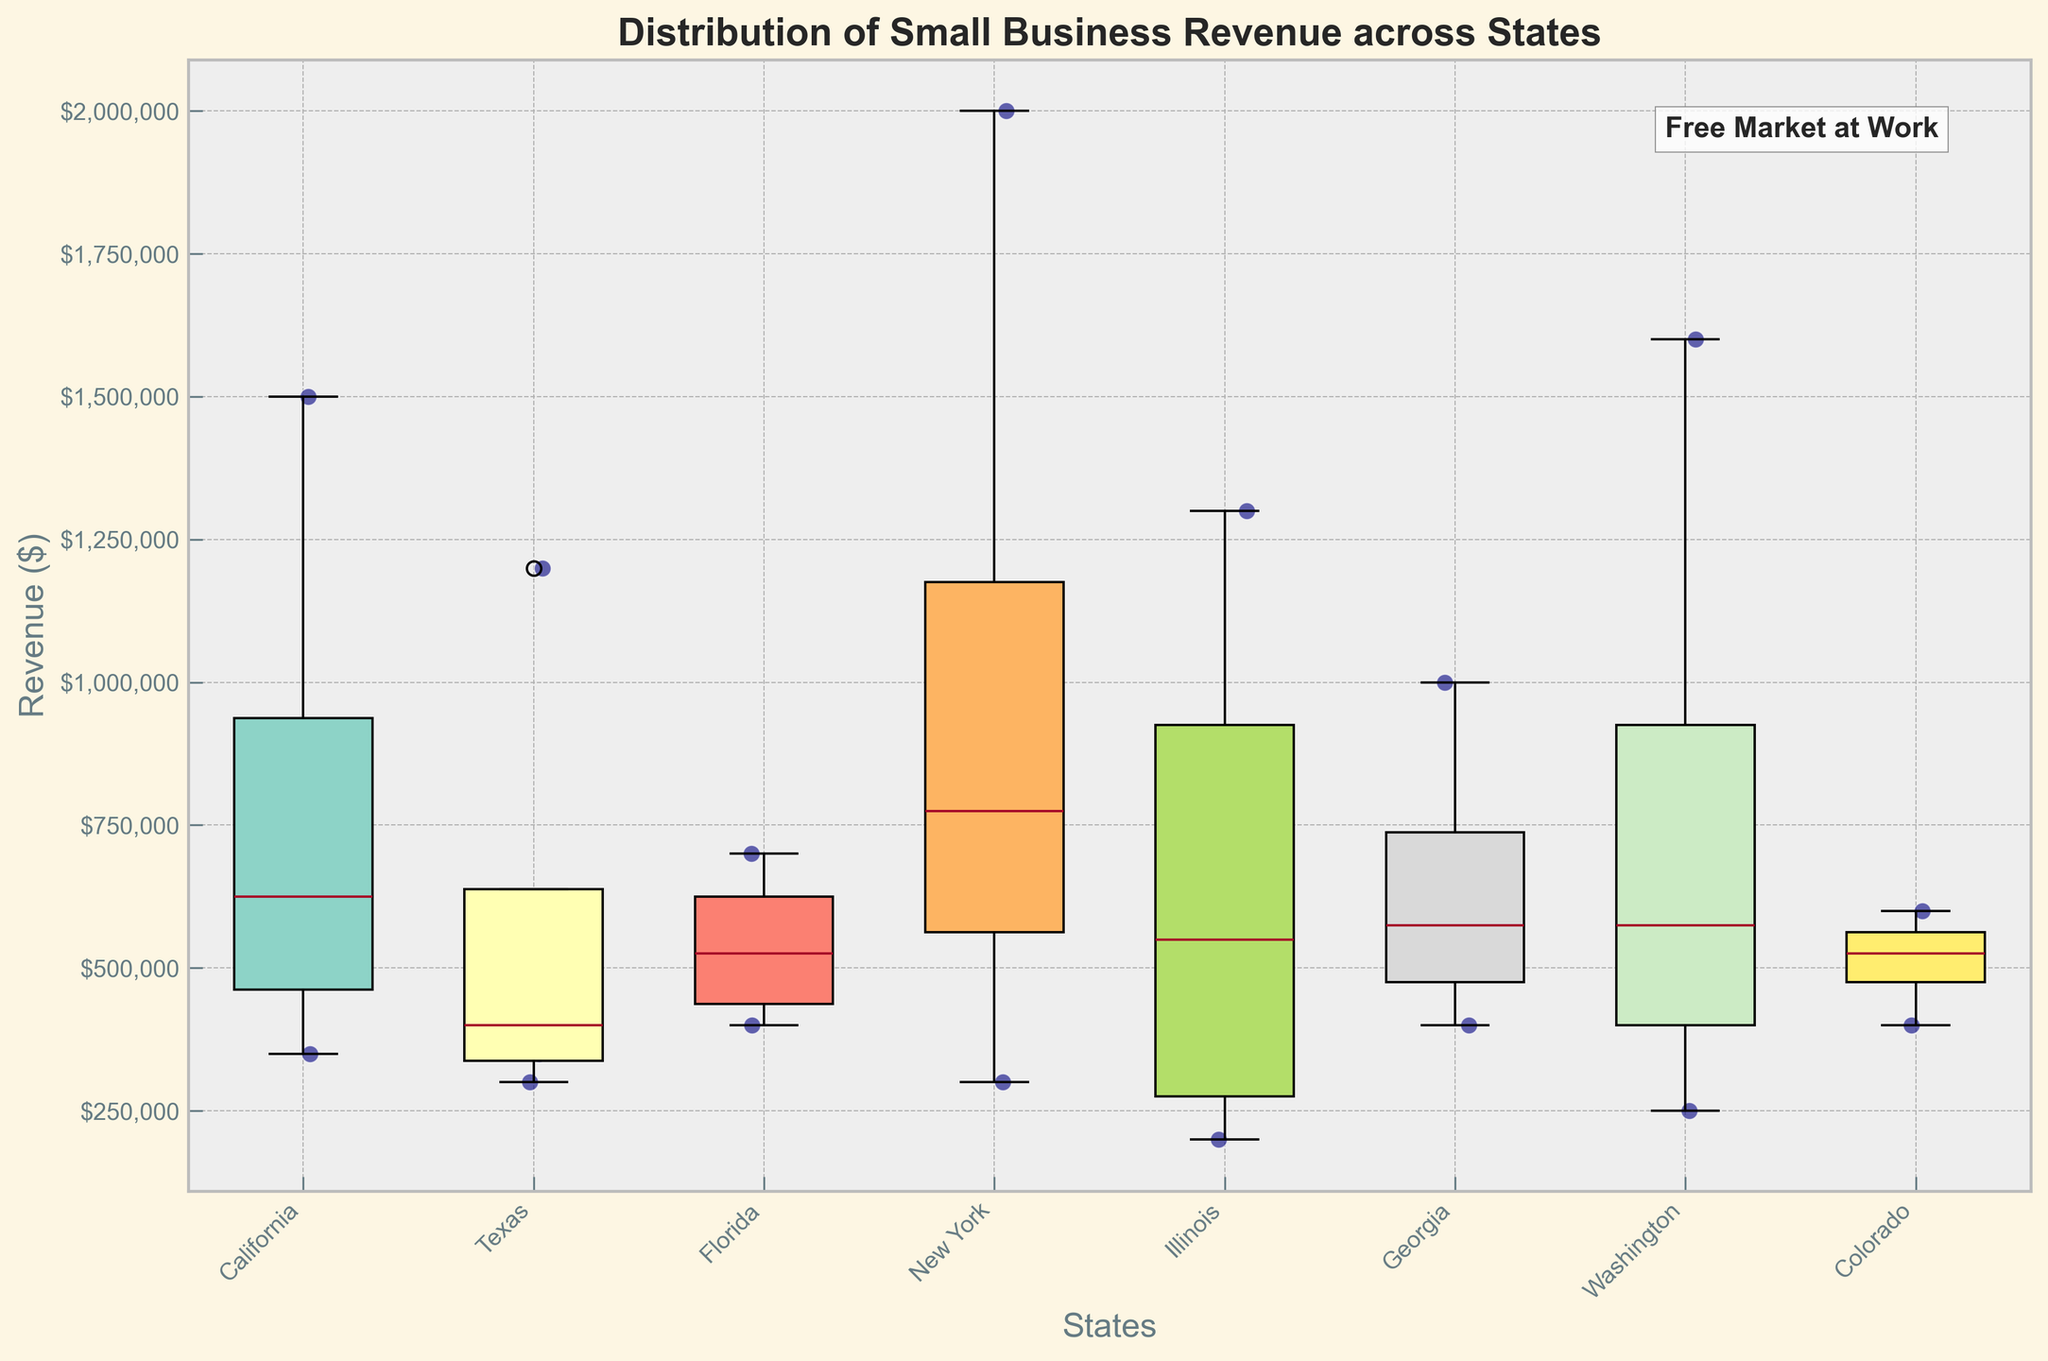What is the title of the plot? The title of the plot is typically located at the top of the image and describes what the plot represents. Here, it states, "Distribution of Small Business Revenue across States" indicating the central theme of the visual.
Answer: Distribution of Small Business Revenue across States What does the y-axis represent in this plot? The y-axis represents the variable that is being measured across the different states. In this plot, it represents the revenue in dollars for small businesses.
Answer: Revenue ($) How many states are represented in the plot? One can count the number of distinct boxes or groups of scatter points along the x-axis to determine the number of states. Each box or clustered scatter points group represents a single state.
Answer: 7 Which state shows the highest median revenue for small businesses? The median revenue for each state is marked by the central line inside each box in the box plot. By comparing these median lines, the state with the highest central line is identified.
Answer: New York How does the revenue distribution in Texas compare to that in Florida? To compare the revenues, observe the spread and central tendency of the boxes and scatter points. Texas generally shows higher revenues with a greater spread, visible by its higher median line and a larger dispersion of scatter points than Florida's.
Answer: Texas has a higher and more spread out revenue distribution than Florida What is the range of revenues for small businesses in California? The range of revenues is determined by looking at the top and bottom lines (whiskers) of California’s box. These lines represent the minimum and maximum values in the revenue distribution for small businesses in California.
Answer: $350,000 to $1,500,000 In which states do small businesses show the lowest minimum revenue? Identify the state(s) with the lowest point of the whiskers in the box plot. The bottommost whisker indicates the lowest minimum revenue observed.
Answer: Illinois and New York How many small businesses in Georgia have revenues above $600,000? Review the scatter points above the $600,000 mark in the revenue axis for Georgia. Count the scatter points to determine the number of businesses exceeding this threshold.
Answer: 2 What is the general trend observed in the scatter points across all states? Generally, scatter points provide insight into the variability and distribution of revenue data across different states. Observing their positioning and spread helps in identifying whether certain states have higher or lower variabilities.
Answer: There is a wide variability in small business revenues across states, with some states showing higher concentrations of higher revenues and some with more uniform distributions What feature of this plot suggests a belief in the free market? Annotations and titles in plots can provide insight into underlying themes or beliefs. Here, the "Free Market at Work" annotation implies a belief in the effectiveness of a market-driven economy without government intervention.
Answer: "Free Market at Work" annotation 